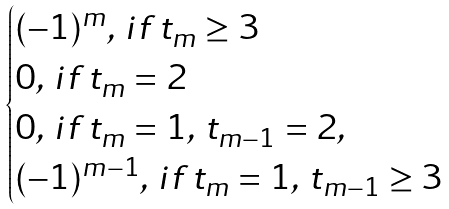Convert formula to latex. <formula><loc_0><loc_0><loc_500><loc_500>\begin{cases} ( - 1 ) ^ { m } , \, i f \, t _ { m } \geq 3 \\ 0 , \, i f \, t _ { m } = 2 \\ 0 , \, i f \, t _ { m } = 1 , \, t _ { m - 1 } = 2 , \\ ( - 1 ) ^ { m - 1 } , \, i f \, t _ { m } = 1 , \, t _ { m - 1 } \geq 3 \end{cases}</formula> 